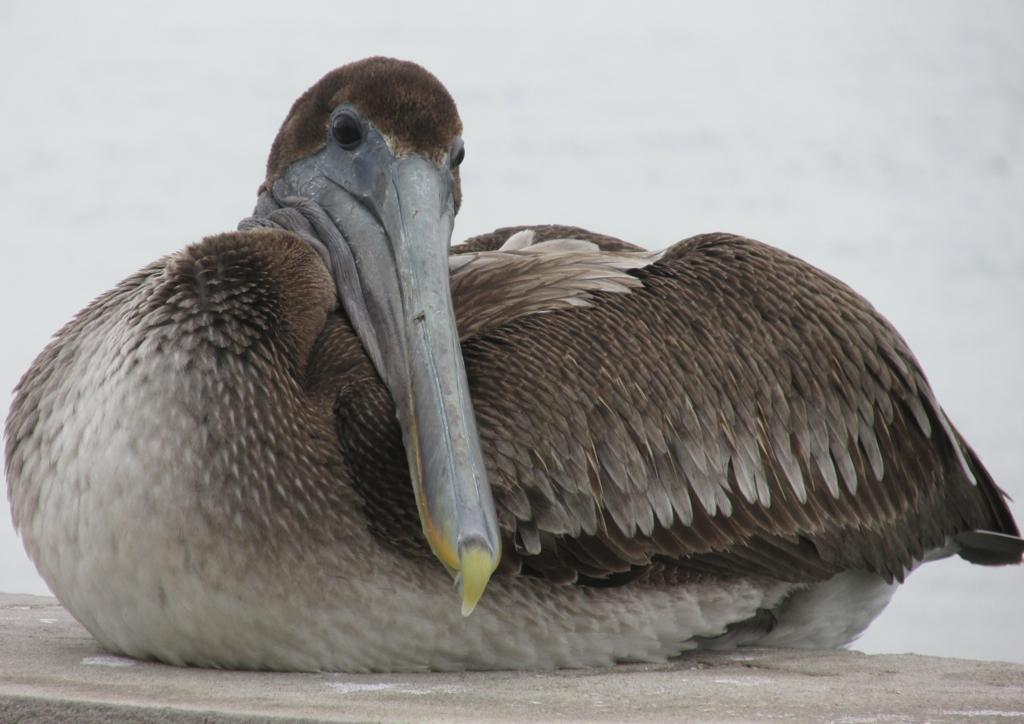What type of animal is in the image? There is a bird in the image. Can you describe the bird's color? The bird has a brown and white color. What does the bird use to communicate with other birds in the image? Birds typically communicate using vocalizations, not a mouth, so it's not possible to determine how the bird communicates in the image. 